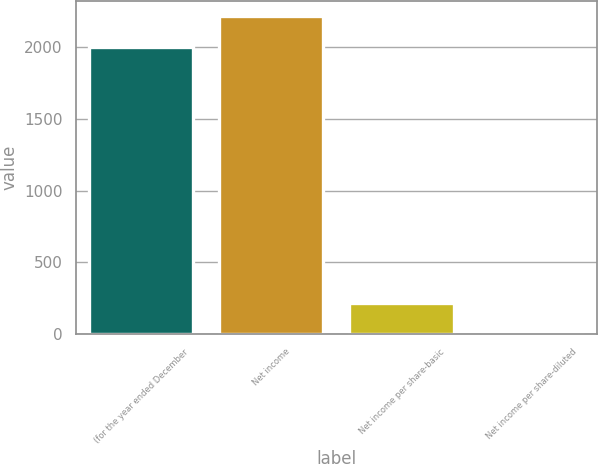Convert chart to OTSL. <chart><loc_0><loc_0><loc_500><loc_500><bar_chart><fcel>(for the year ended December<fcel>Net income<fcel>Net income per share-basic<fcel>Net income per share-diluted<nl><fcel>2003<fcel>2214.99<fcel>215.08<fcel>3.09<nl></chart> 